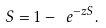<formula> <loc_0><loc_0><loc_500><loc_500>S = 1 - \ e ^ { - z S } .</formula> 